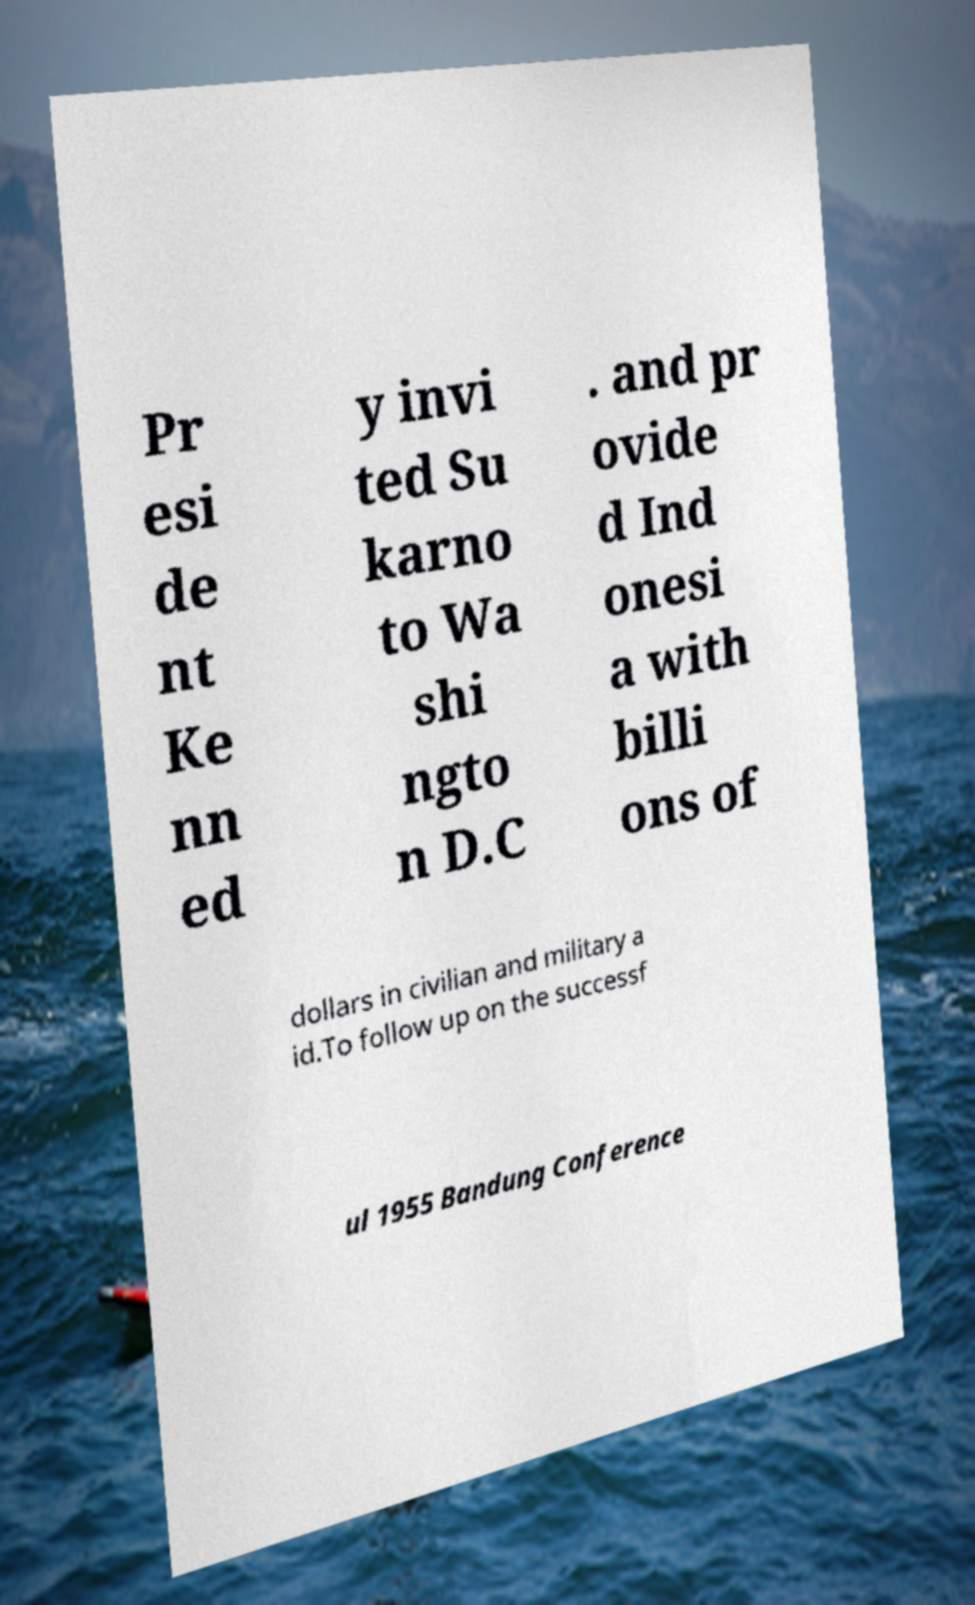Can you read and provide the text displayed in the image?This photo seems to have some interesting text. Can you extract and type it out for me? Pr esi de nt Ke nn ed y invi ted Su karno to Wa shi ngto n D.C . and pr ovide d Ind onesi a with billi ons of dollars in civilian and military a id.To follow up on the successf ul 1955 Bandung Conference 